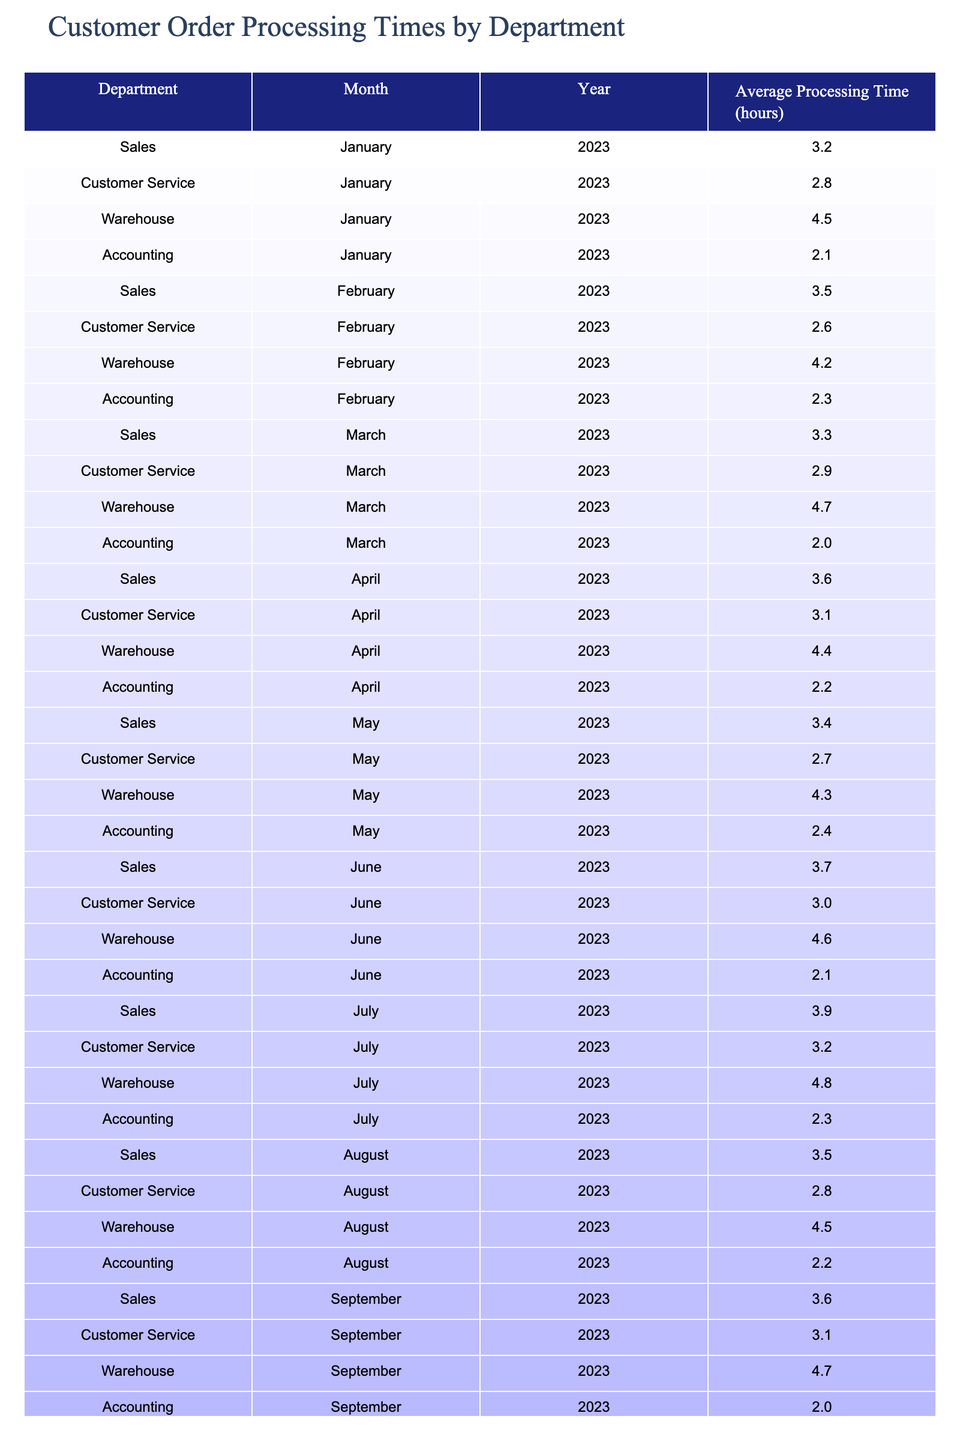What is the average processing time for the Warehouse department in December 2023? Looking at the table, the average processing time for the Warehouse department in December 2023 is listed directly as 4.9 hours.
Answer: 4.9 hours Which department had the shortest average processing time in January 2023? From the table, the average processing times for January 2023 are: Sales (3.2), Customer Service (2.8), Warehouse (4.5), and Accounting (2.1). The shortest time is for Accounting at 2.1 hours.
Answer: Accounting What is the total average processing time for Customer Service across all months? To calculate the total for Customer Service, add the monthly averages: 2.8 + 2.6 + 2.9 + 3.1 + 2.7 + 3.0 + 3.2 + 3.0 = 22.3 hours. The total average is then 22.3/8 = 2.79 hours (rounded to two decimal places).
Answer: 2.79 hours Did the Accounting department process orders faster on average in August than in July? The table shows that the average processing time for Accounting in August is 2.2 hours and in July is 2.3 hours. Since 2.2 is less than 2.3, Accounting was faster in August.
Answer: Yes What is the difference in average processing time between Sales and Warehouse departments in March 2023? In March 2023, Sales had an average time of 3.3 hours and Warehouse had 4.7 hours. The difference is 4.7 - 3.3 = 1.4 hours.
Answer: 1.4 hours Which month in 2023 had the highest average processing time for the Warehouse department? Inspecting the table, the average processing times for the Warehouse department across months are: January (4.5), February (4.2), March (4.7), April (4.4), May (4.3), June (4.6), July (4.8), August (4.5), September (4.7), October (4.4), November (4.6), December (4.9). December 2023 had the highest average processing time of 4.9 hours.
Answer: December 2023 Is the average processing time for Sales in April greater than that in June? The average processing time for Sales in April is 3.6 hours, and in June, it is 3.7 hours. Since 3.6 is less than 3.7, it is not greater in April.
Answer: No What is the average processing time for all departments combined in July 2023? For July: Sales (3.9) + Customer Service (3.2) + Warehouse (4.8) + Accounting (2.3) = 14.2 hours combined. The average is 14.2/4 = 3.55 hours.
Answer: 3.55 hours Which department consistently has the highest processing times in the first half of 2023? Reviewing the first half of 2023, Warehouse registration times: January (4.5), February (4.2), March (4.7), April (4.4), May (4.3), June (4.6) indicates it has the highest times in all those months compared to others.
Answer: Warehouse What is the median processing time for Customer Service across the 12 months of 2023? Listing the Customer Service processing times: 2.6, 2.7, 2.8, 2.9, 3.0, 3.0, 3.1, 3.2, sorted gives us: 2.6, 2.7, 2.8, 2.9, 3.0, 3.0, 3.1, 3.2. The median, being the average of the 6th and 7th values (3.0 and 3.1), is (3.0 + 3.1)/2 = 3.05.
Answer: 3.05 